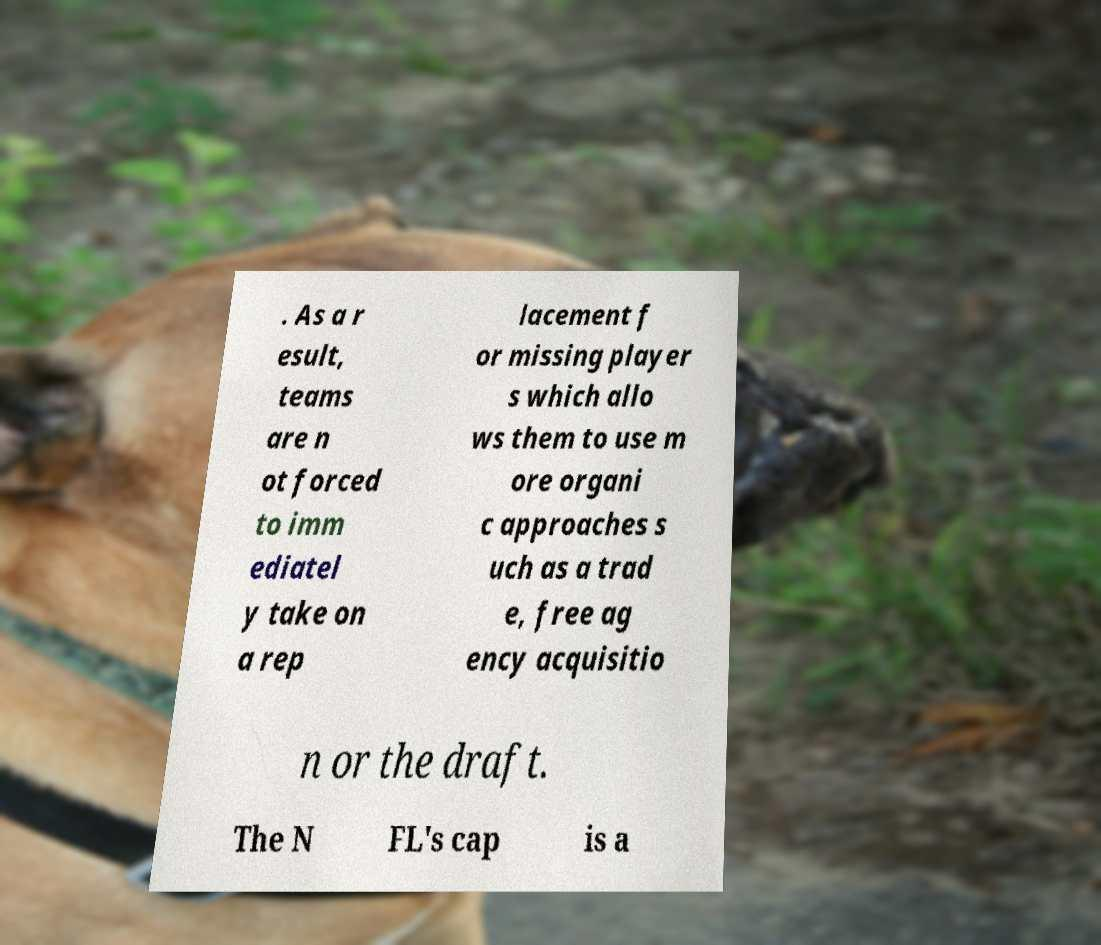Please identify and transcribe the text found in this image. . As a r esult, teams are n ot forced to imm ediatel y take on a rep lacement f or missing player s which allo ws them to use m ore organi c approaches s uch as a trad e, free ag ency acquisitio n or the draft. The N FL's cap is a 